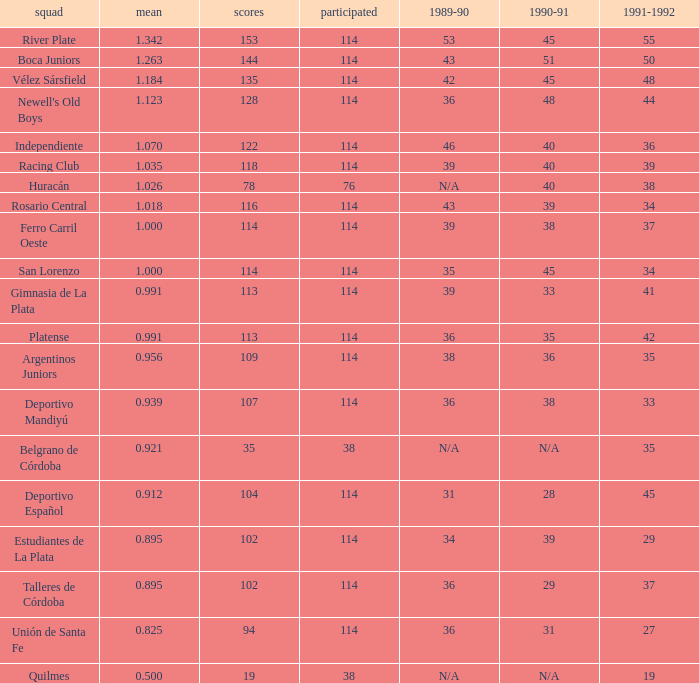How much Average has a 1989-90 of 36, and a Team of talleres de córdoba, and a Played smaller than 114? 0.0. 